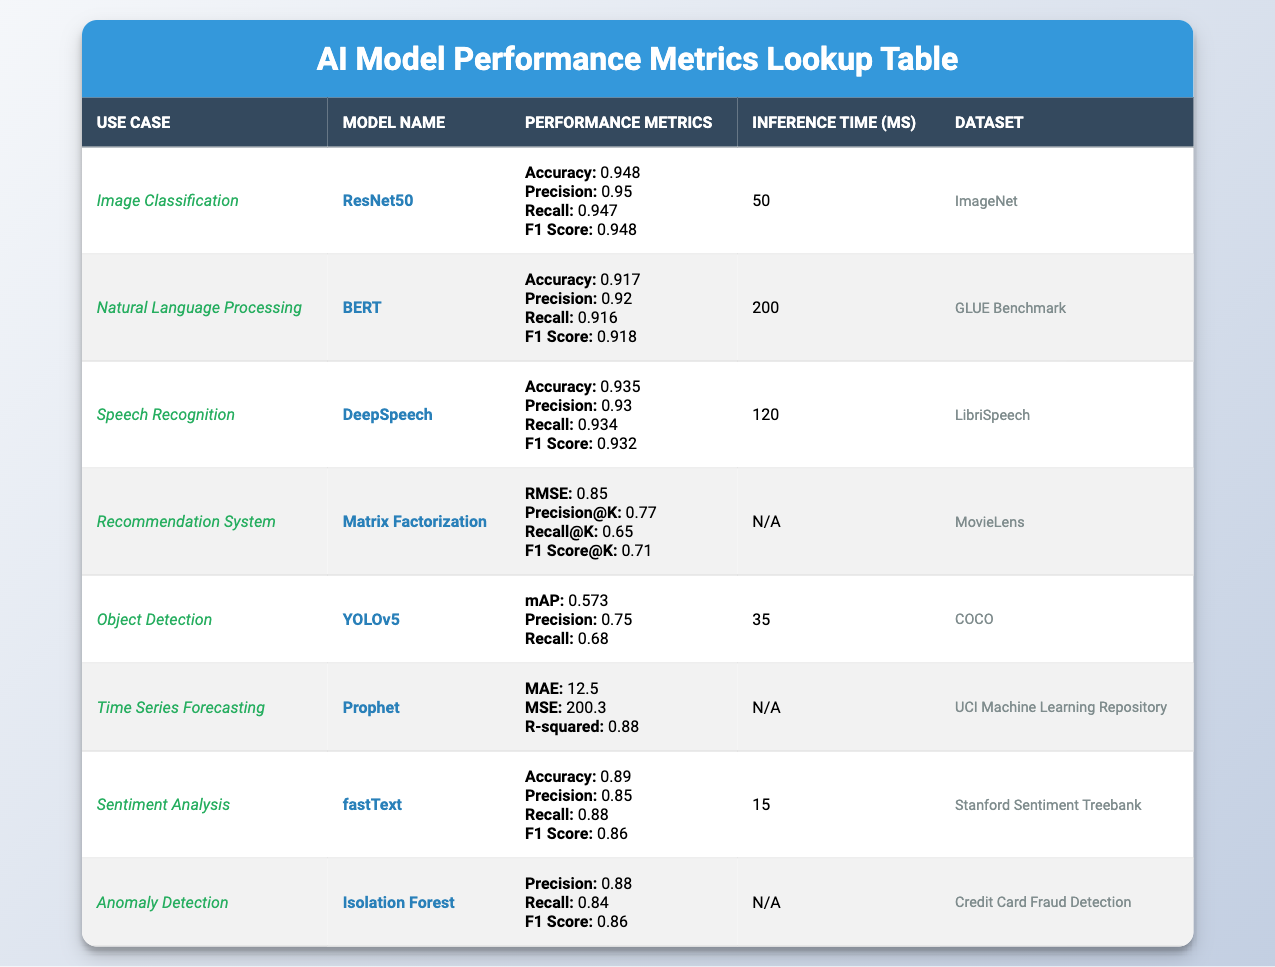What is the accuracy of the ResNet50 model for Image Classification? The accuracy for the ResNet50 model, which is used for Image Classification, is directly listed in the table as 0.948.
Answer: 0.948 Which model has the lowest inference time, and what is that time? The inference times of the models are 50 ms for ResNet50, 200 ms for BERT, 120 ms for DeepSpeech, 35 ms for YOLOv5, 15 ms for fastText, and N/A for others. YOLOv5 has the lowest inference time of 35 ms.
Answer: YOLOv5, 35 ms What is the F1 score for the BERT model in Natural Language Processing? The F1 score for the BERT model, found in the metrics for Natural Language Processing, is listed as 0.918 in the table.
Answer: 0.918 Is the recall for the fastText model in Sentiment Analysis greater than 0.85? The recall for the fastText model in Sentiment Analysis is given in the table as 0.88, which is indeed greater than 0.85, making the statement true.
Answer: Yes What is the difference in F1 scores between DeepSpeech and Isolation Forest? The F1 score for DeepSpeech in Speech Recognition is 0.932, while for Isolation Forest in Anomaly Detection, it's 0.86. Calculating the difference gives 0.932 - 0.86 = 0.072.
Answer: 0.072 Which use case has the highest accuracy? The accuracies from the various use cases are as follows: Image Classification (0.948), Natural Language Processing (0.917), Speech Recognition (0.935), and Sentiment Analysis (0.89). The highest accuracy is 0.948 for Image Classification, which corresponds to the ResNet50 model.
Answer: Image Classification, 0.948 What is the average precision at k for the Recommendation System model? The precision at k for the Matrix Factorization model used in the Recommendation System is recorded as 0.77, and this is the only value provided, making the average equal to 0.77.
Answer: 0.77 Is there any model listed that uses the dataset "COCO"? From the table, it is noted that the YOLOv5 model for Object Detection uses the COCO dataset, confirming that there is a model listed utilizing this dataset.
Answer: Yes How would you compare the mean absolute error of Prophet with the RMSE of the Recommendation System? The mean absolute error (MAE) for Prophet in Time Series Forecasting is 12.5, while the RMSE for the Matrix Factorization model in the Recommendation System is 0.85. There is no direct comparison since they measure different things, but both models have metrics related to their performance.
Answer: Not directly comparable 